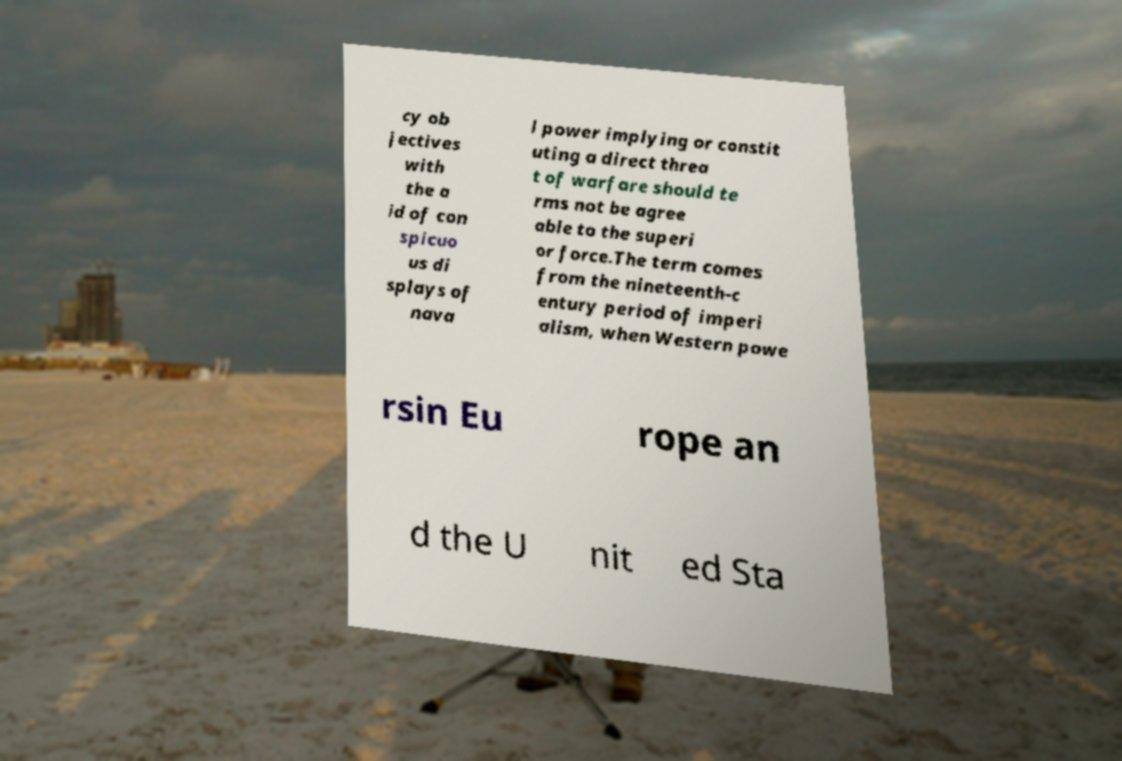What messages or text are displayed in this image? I need them in a readable, typed format. cy ob jectives with the a id of con spicuo us di splays of nava l power implying or constit uting a direct threa t of warfare should te rms not be agree able to the superi or force.The term comes from the nineteenth-c entury period of imperi alism, when Western powe rsin Eu rope an d the U nit ed Sta 